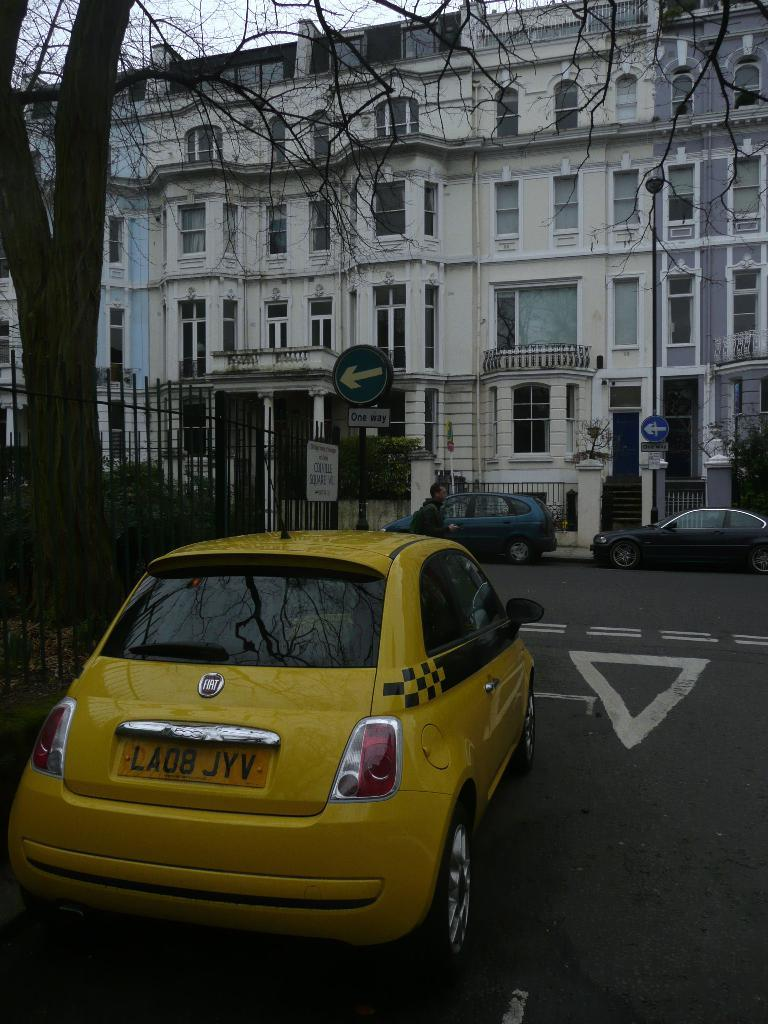<image>
Present a compact description of the photo's key features. Yellow Fiat with license plate number LA08 JYV. 